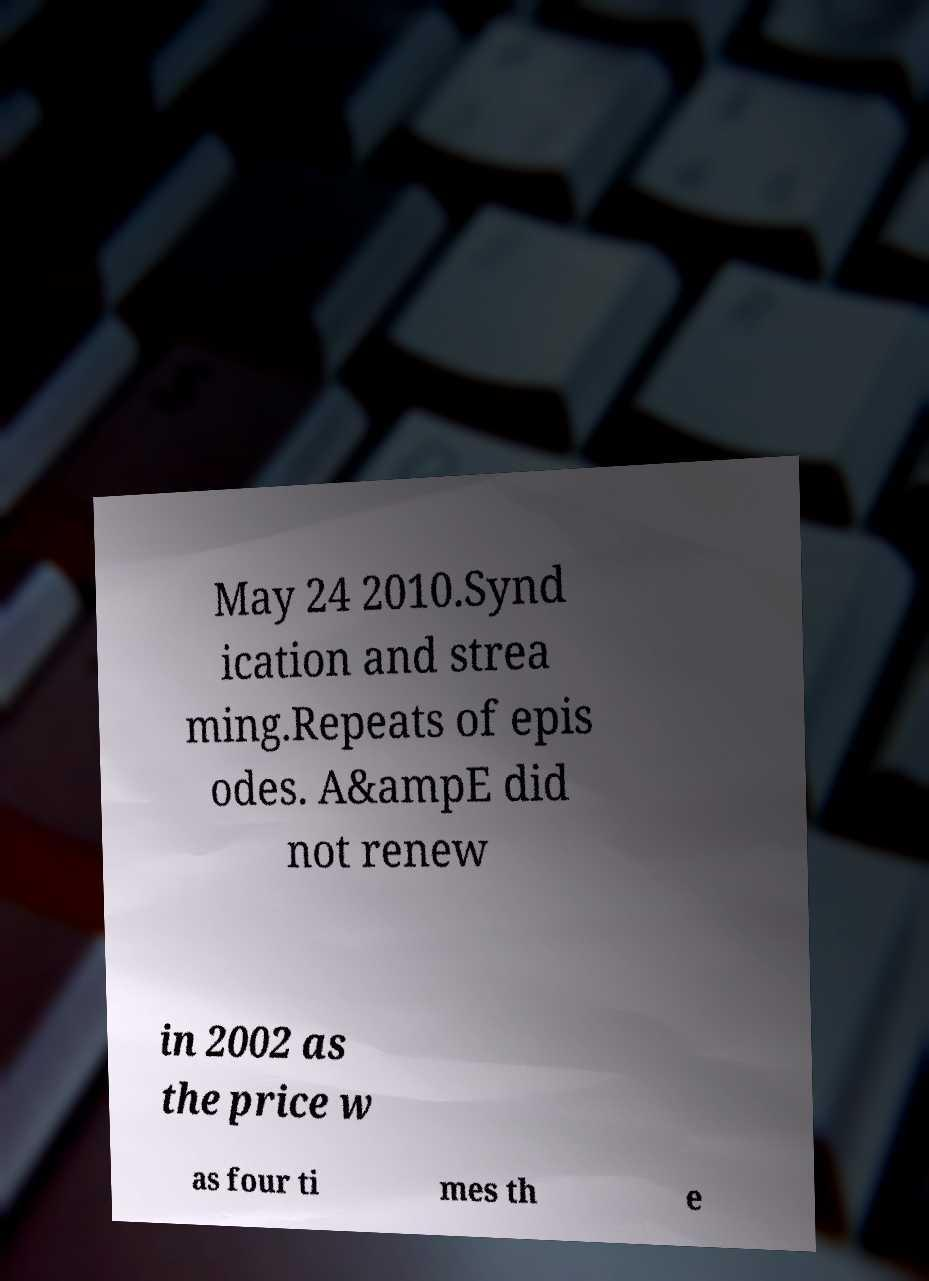Could you assist in decoding the text presented in this image and type it out clearly? May 24 2010.Synd ication and strea ming.Repeats of epis odes. A&ampE did not renew in 2002 as the price w as four ti mes th e 